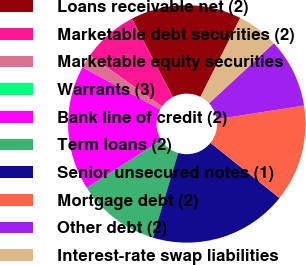Convert chart to OTSL. <chart><loc_0><loc_0><loc_500><loc_500><pie_chart><fcel>Loans receivable net (2)<fcel>Marketable debt securities (2)<fcel>Marketable equity securities<fcel>Warrants (3)<fcel>Bank line of credit (2)<fcel>Term loans (2)<fcel>Senior unsecured notes (1)<fcel>Mortgage debt (2)<fcel>Other debt (2)<fcel>Interest-rate swap liabilities<nl><fcel>15.09%<fcel>7.55%<fcel>1.89%<fcel>0.0%<fcel>16.98%<fcel>11.32%<fcel>18.87%<fcel>13.21%<fcel>9.43%<fcel>5.66%<nl></chart> 